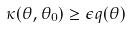<formula> <loc_0><loc_0><loc_500><loc_500>\kappa ( \theta , \theta _ { 0 } ) \geq \epsilon q ( \theta )</formula> 